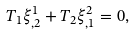<formula> <loc_0><loc_0><loc_500><loc_500>T _ { 1 } \xi ^ { 1 } _ { , 2 } + T _ { 2 } \xi ^ { 2 } _ { , 1 } = 0 ,</formula> 